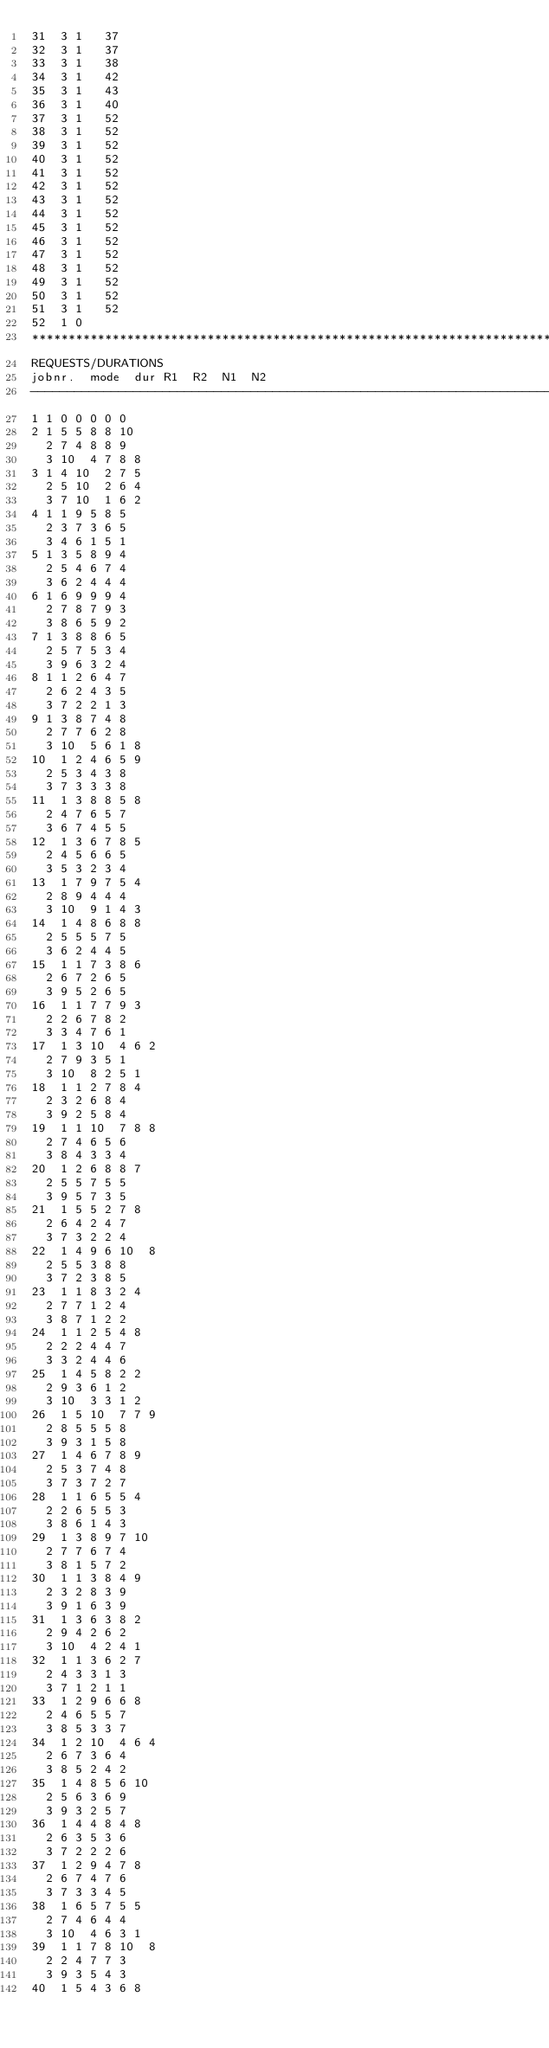<code> <loc_0><loc_0><loc_500><loc_500><_ObjectiveC_>31	3	1		37 
32	3	1		37 
33	3	1		38 
34	3	1		42 
35	3	1		43 
36	3	1		40 
37	3	1		52 
38	3	1		52 
39	3	1		52 
40	3	1		52 
41	3	1		52 
42	3	1		52 
43	3	1		52 
44	3	1		52 
45	3	1		52 
46	3	1		52 
47	3	1		52 
48	3	1		52 
49	3	1		52 
50	3	1		52 
51	3	1		52 
52	1	0		
************************************************************************
REQUESTS/DURATIONS
jobnr.	mode	dur	R1	R2	N1	N2	
------------------------------------------------------------------------
1	1	0	0	0	0	0	
2	1	5	5	8	8	10	
	2	7	4	8	8	9	
	3	10	4	7	8	8	
3	1	4	10	2	7	5	
	2	5	10	2	6	4	
	3	7	10	1	6	2	
4	1	1	9	5	8	5	
	2	3	7	3	6	5	
	3	4	6	1	5	1	
5	1	3	5	8	9	4	
	2	5	4	6	7	4	
	3	6	2	4	4	4	
6	1	6	9	9	9	4	
	2	7	8	7	9	3	
	3	8	6	5	9	2	
7	1	3	8	8	6	5	
	2	5	7	5	3	4	
	3	9	6	3	2	4	
8	1	1	2	6	4	7	
	2	6	2	4	3	5	
	3	7	2	2	1	3	
9	1	3	8	7	4	8	
	2	7	7	6	2	8	
	3	10	5	6	1	8	
10	1	2	4	6	5	9	
	2	5	3	4	3	8	
	3	7	3	3	3	8	
11	1	3	8	8	5	8	
	2	4	7	6	5	7	
	3	6	7	4	5	5	
12	1	3	6	7	8	5	
	2	4	5	6	6	5	
	3	5	3	2	3	4	
13	1	7	9	7	5	4	
	2	8	9	4	4	4	
	3	10	9	1	4	3	
14	1	4	8	6	8	8	
	2	5	5	5	7	5	
	3	6	2	4	4	5	
15	1	1	7	3	8	6	
	2	6	7	2	6	5	
	3	9	5	2	6	5	
16	1	1	7	7	9	3	
	2	2	6	7	8	2	
	3	3	4	7	6	1	
17	1	3	10	4	6	2	
	2	7	9	3	5	1	
	3	10	8	2	5	1	
18	1	1	2	7	8	4	
	2	3	2	6	8	4	
	3	9	2	5	8	4	
19	1	1	10	7	8	8	
	2	7	4	6	5	6	
	3	8	4	3	3	4	
20	1	2	6	8	8	7	
	2	5	5	7	5	5	
	3	9	5	7	3	5	
21	1	5	5	2	7	8	
	2	6	4	2	4	7	
	3	7	3	2	2	4	
22	1	4	9	6	10	8	
	2	5	5	3	8	8	
	3	7	2	3	8	5	
23	1	1	8	3	2	4	
	2	7	7	1	2	4	
	3	8	7	1	2	2	
24	1	1	2	5	4	8	
	2	2	2	4	4	7	
	3	3	2	4	4	6	
25	1	4	5	8	2	2	
	2	9	3	6	1	2	
	3	10	3	3	1	2	
26	1	5	10	7	7	9	
	2	8	5	5	5	8	
	3	9	3	1	5	8	
27	1	4	6	7	8	9	
	2	5	3	7	4	8	
	3	7	3	7	2	7	
28	1	1	6	5	5	4	
	2	2	6	5	5	3	
	3	8	6	1	4	3	
29	1	3	8	9	7	10	
	2	7	7	6	7	4	
	3	8	1	5	7	2	
30	1	1	3	8	4	9	
	2	3	2	8	3	9	
	3	9	1	6	3	9	
31	1	3	6	3	8	2	
	2	9	4	2	6	2	
	3	10	4	2	4	1	
32	1	1	3	6	2	7	
	2	4	3	3	1	3	
	3	7	1	2	1	1	
33	1	2	9	6	6	8	
	2	4	6	5	5	7	
	3	8	5	3	3	7	
34	1	2	10	4	6	4	
	2	6	7	3	6	4	
	3	8	5	2	4	2	
35	1	4	8	5	6	10	
	2	5	6	3	6	9	
	3	9	3	2	5	7	
36	1	4	4	8	4	8	
	2	6	3	5	3	6	
	3	7	2	2	2	6	
37	1	2	9	4	7	8	
	2	6	7	4	7	6	
	3	7	3	3	4	5	
38	1	6	5	7	5	5	
	2	7	4	6	4	4	
	3	10	4	6	3	1	
39	1	1	7	8	10	8	
	2	2	4	7	7	3	
	3	9	3	5	4	3	
40	1	5	4	3	6	8	</code> 